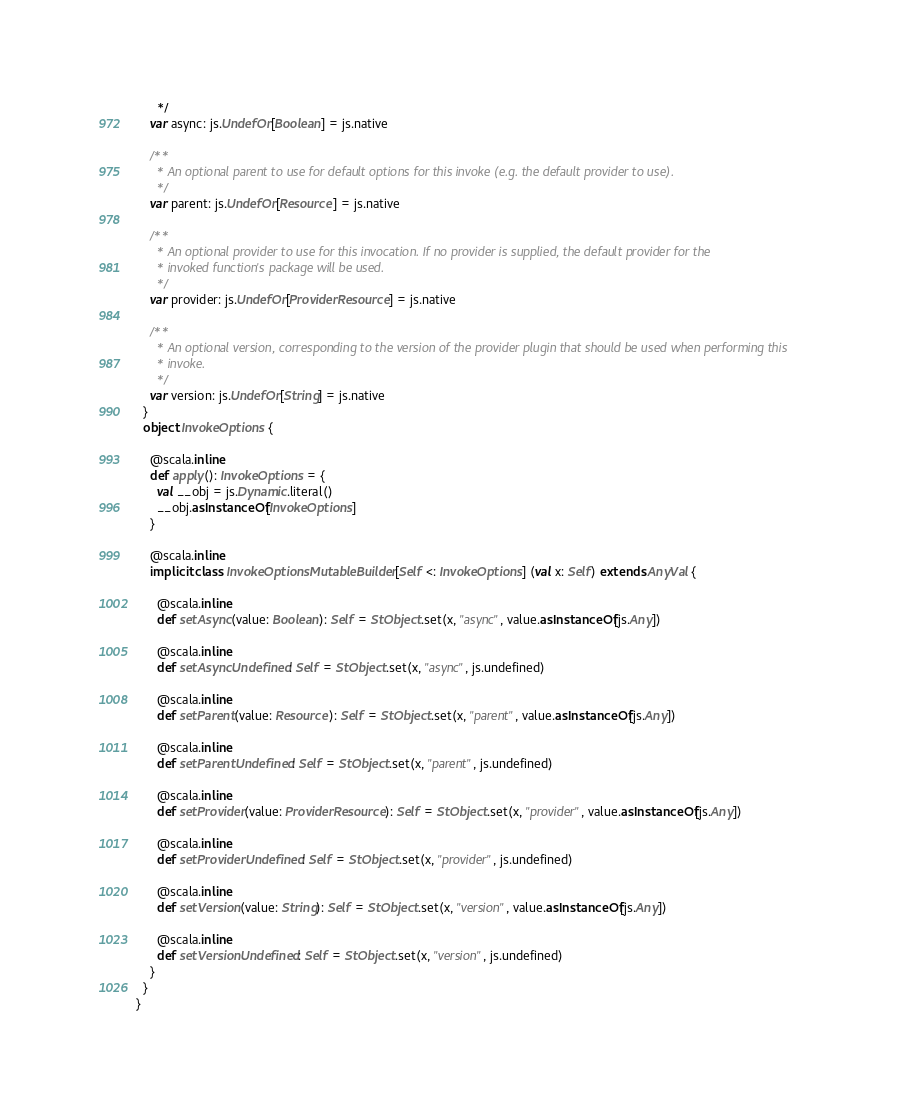Convert code to text. <code><loc_0><loc_0><loc_500><loc_500><_Scala_>      */
    var async: js.UndefOr[Boolean] = js.native
    
    /**
      * An optional parent to use for default options for this invoke (e.g. the default provider to use).
      */
    var parent: js.UndefOr[Resource] = js.native
    
    /**
      * An optional provider to use for this invocation. If no provider is supplied, the default provider for the
      * invoked function's package will be used.
      */
    var provider: js.UndefOr[ProviderResource] = js.native
    
    /**
      * An optional version, corresponding to the version of the provider plugin that should be used when performing this
      * invoke.
      */
    var version: js.UndefOr[String] = js.native
  }
  object InvokeOptions {
    
    @scala.inline
    def apply(): InvokeOptions = {
      val __obj = js.Dynamic.literal()
      __obj.asInstanceOf[InvokeOptions]
    }
    
    @scala.inline
    implicit class InvokeOptionsMutableBuilder[Self <: InvokeOptions] (val x: Self) extends AnyVal {
      
      @scala.inline
      def setAsync(value: Boolean): Self = StObject.set(x, "async", value.asInstanceOf[js.Any])
      
      @scala.inline
      def setAsyncUndefined: Self = StObject.set(x, "async", js.undefined)
      
      @scala.inline
      def setParent(value: Resource): Self = StObject.set(x, "parent", value.asInstanceOf[js.Any])
      
      @scala.inline
      def setParentUndefined: Self = StObject.set(x, "parent", js.undefined)
      
      @scala.inline
      def setProvider(value: ProviderResource): Self = StObject.set(x, "provider", value.asInstanceOf[js.Any])
      
      @scala.inline
      def setProviderUndefined: Self = StObject.set(x, "provider", js.undefined)
      
      @scala.inline
      def setVersion(value: String): Self = StObject.set(x, "version", value.asInstanceOf[js.Any])
      
      @scala.inline
      def setVersionUndefined: Self = StObject.set(x, "version", js.undefined)
    }
  }
}
</code> 